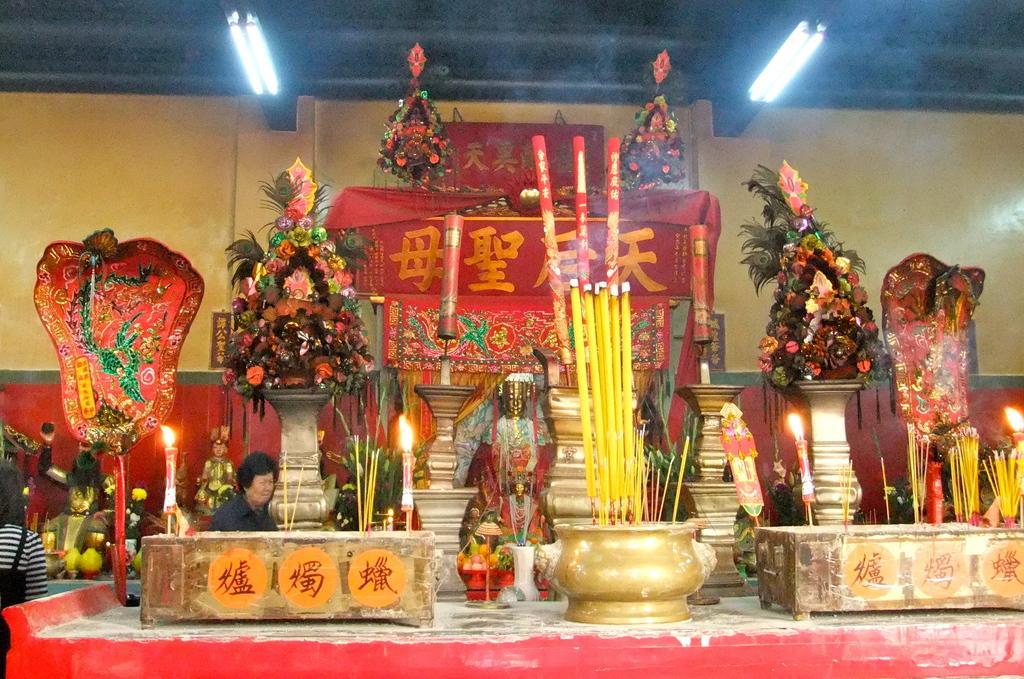Describe this image in one or two sentences. In this image, we can see some Idols. We can see a few candles. We can see some flowers, peacock feathers. We can also see some objects. There are a few people. We can see the ground and the wall. 